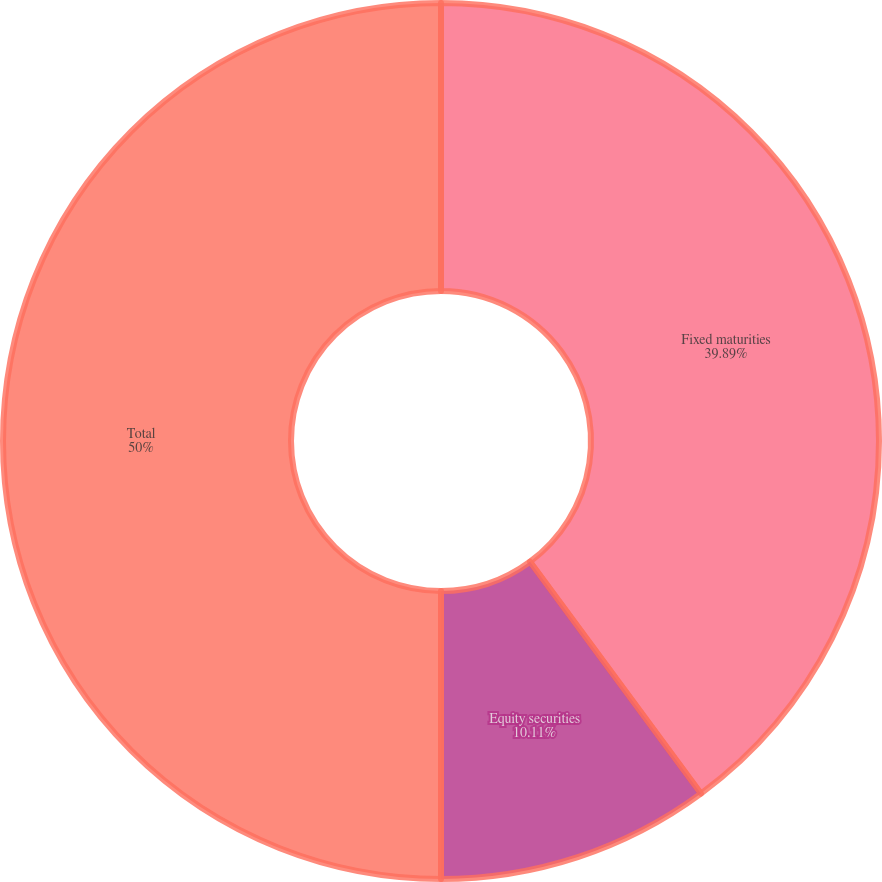<chart> <loc_0><loc_0><loc_500><loc_500><pie_chart><fcel>Fixed maturities<fcel>Equity securities<fcel>Total<nl><fcel>39.89%<fcel>10.11%<fcel>50.0%<nl></chart> 